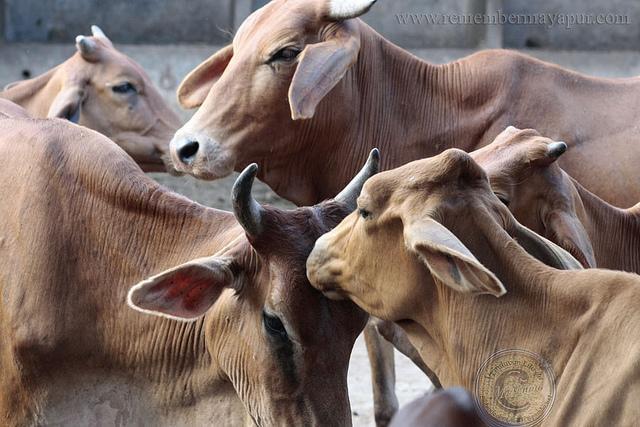How many animals are there?
Give a very brief answer. 5. How many cows are in the photo?
Give a very brief answer. 5. 